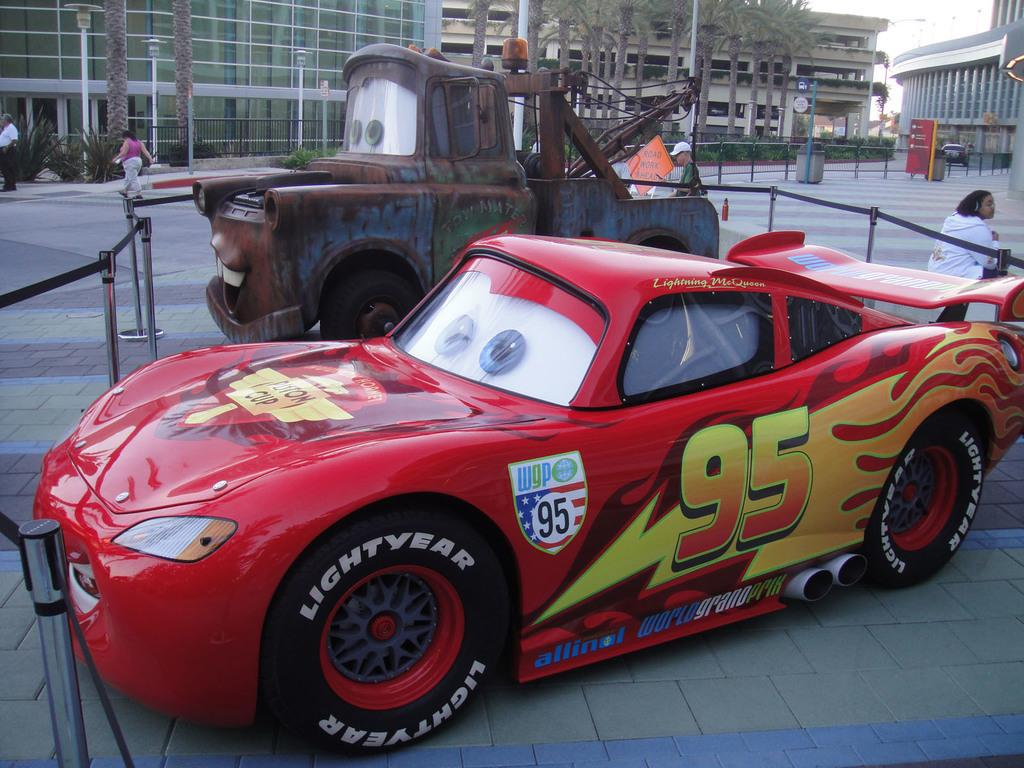What color is the car in the image? The car in the image is red. What is in front of the car in the image? There is a ribbon in front of the car. What can be seen in the background of the image? There are buildings and trees in the background of the image. What type of operation is being performed on the car's fang in the image? There is no mention of a fang or any operation being performed on the car in the image. 